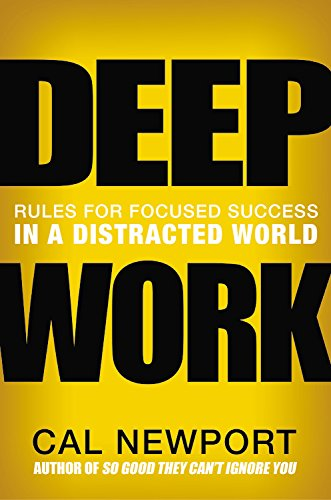What are some key benefits of adopting the principles outlined in this book? Adopting principles of 'Deep Work' helps in drastically improving one's productivity, efficiency, and the quality of outputs. It enhances the ability to master complex information and skills rapidly, and also contributes to a greater sense of fulfillment from your professional life. Could you provide a real-world example or case study that illustrates these benefits? Certainly! One profound example is Bill Gates, who is known for taking 'Think Weeks' where he disconnects from daily business operations to focus deeply on reading and innovation. This practice has been crucial for developing new strategies for Microsoft and initiating innovative projects. 